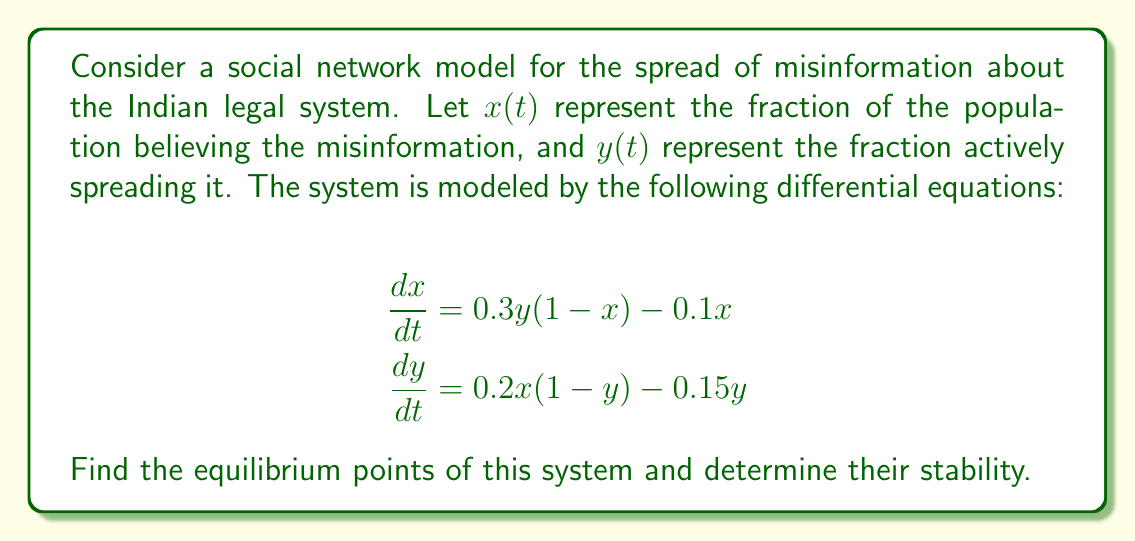Could you help me with this problem? 1) To find the equilibrium points, set both derivatives to zero:

   $$0.3y(1-x) - 0.1x = 0 \quad (1)$$
   $$0.2x(1-y) - 0.15y = 0 \quad (2)$$

2) From equation (1):
   $$0.3y - 0.3xy - 0.1x = 0$$
   $$0.3y = 0.3xy + 0.1x$$
   $$y = x + \frac{1}{3}$$

3) Substitute this into equation (2):
   $$0.2x(1-(x+\frac{1}{3})) - 0.15(x+\frac{1}{3}) = 0$$
   $$0.2x(\frac{2}{3}-x) - 0.15x - 0.05 = 0$$
   $$0.13333x - 0.2x^2 - 0.15x - 0.05 = 0$$
   $$-0.2x^2 - 0.01667x - 0.05 = 0$$

4) Solve this quadratic equation:
   $$x = \frac{-(-0.01667) \pm \sqrt{(-0.01667)^2 - 4(-0.2)(-0.05)}}{2(-0.2)}$$
   $$x \approx 0.5 \text{ or } x \approx -0.5415$$

5) Since x represents a fraction of the population, we discard the negative solution. Therefore, the equilibrium point is:
   $$(x^*, y^*) \approx (0.5, 0.8333)$$

6) To determine stability, calculate the Jacobian matrix at the equilibrium point:
   $$J = \begin{bmatrix} 
   -0.3y-0.1 & 0.3(1-x) \\
   0.2(1-y) & -0.2x-0.15
   \end{bmatrix}$$

7) Evaluate at (0.5, 0.8333):
   $$J \approx \begin{bmatrix} 
   -0.35 & 0.15 \\
   0.0334 & -0.25
   \end{bmatrix}$$

8) Calculate eigenvalues:
   $$det(J-\lambda I) = \begin{vmatrix} 
   -0.35-\lambda & 0.15 \\
   0.0334 & -0.25-\lambda
   \end{vmatrix} = 0$$
   
   $$\lambda^2 + 0.6\lambda + 0.0834 = 0$$
   
   $$\lambda \approx -0.5236 \text{ or } -0.0764$$

9) Both eigenvalues are negative, so the equilibrium point is stable.
Answer: Stable equilibrium point at $(x^*, y^*) \approx (0.5, 0.8333)$ 